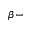Convert formula to latex. <formula><loc_0><loc_0><loc_500><loc_500>\beta -</formula> 